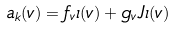<formula> <loc_0><loc_0><loc_500><loc_500>a _ { k } ( v ) = f _ { v } \iota ( v ) + g _ { v } J \iota ( v )</formula> 